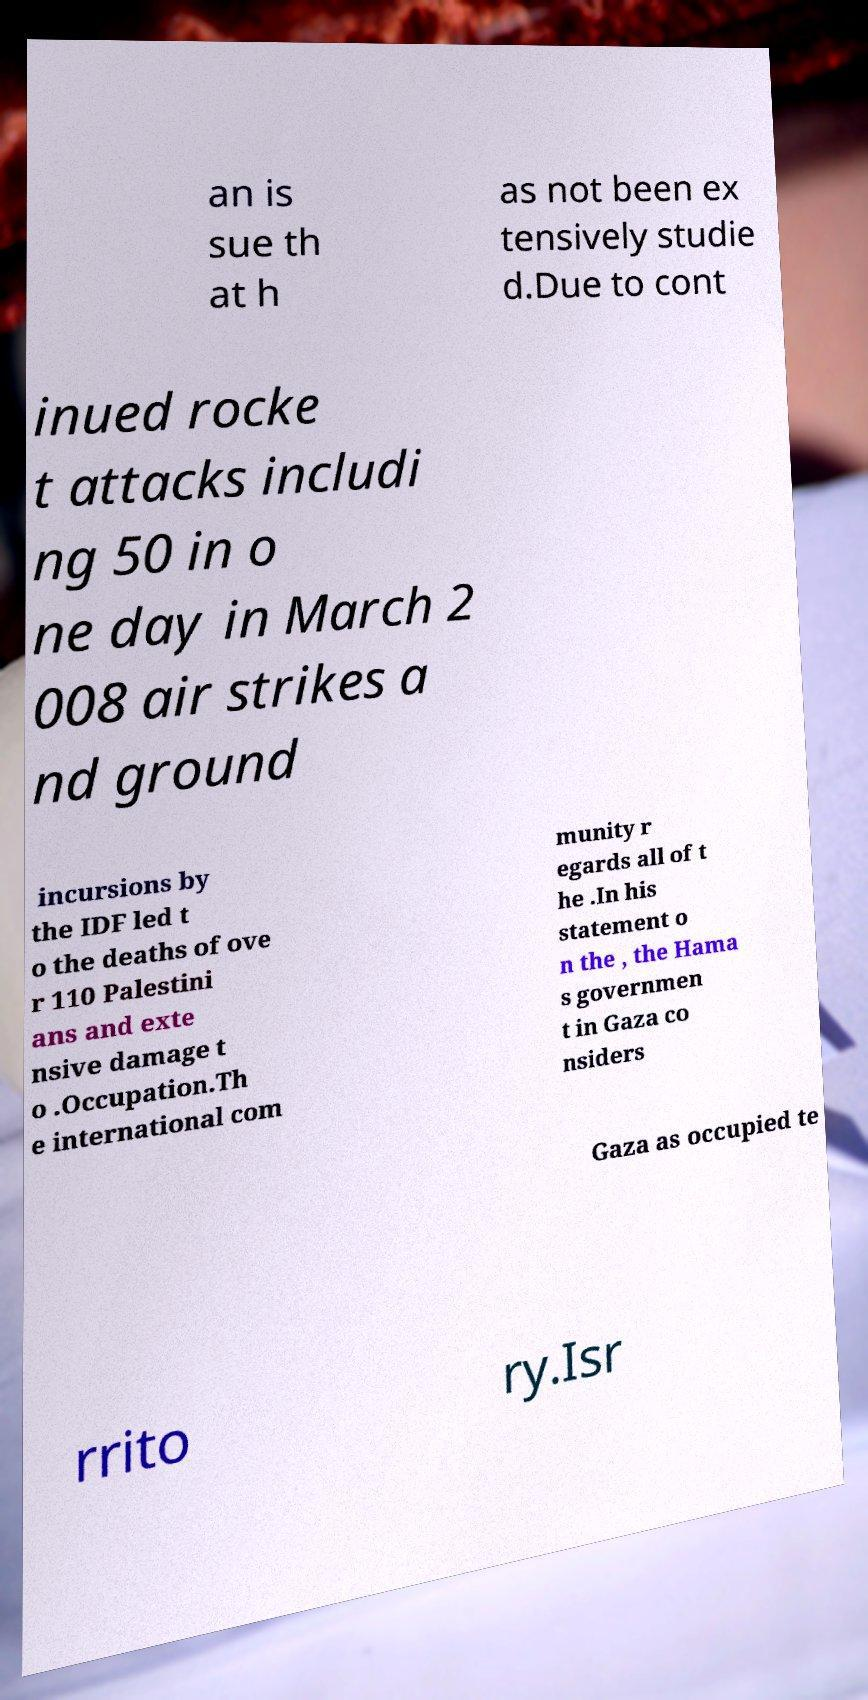For documentation purposes, I need the text within this image transcribed. Could you provide that? an is sue th at h as not been ex tensively studie d.Due to cont inued rocke t attacks includi ng 50 in o ne day in March 2 008 air strikes a nd ground incursions by the IDF led t o the deaths of ove r 110 Palestini ans and exte nsive damage t o .Occupation.Th e international com munity r egards all of t he .In his statement o n the , the Hama s governmen t in Gaza co nsiders Gaza as occupied te rrito ry.Isr 